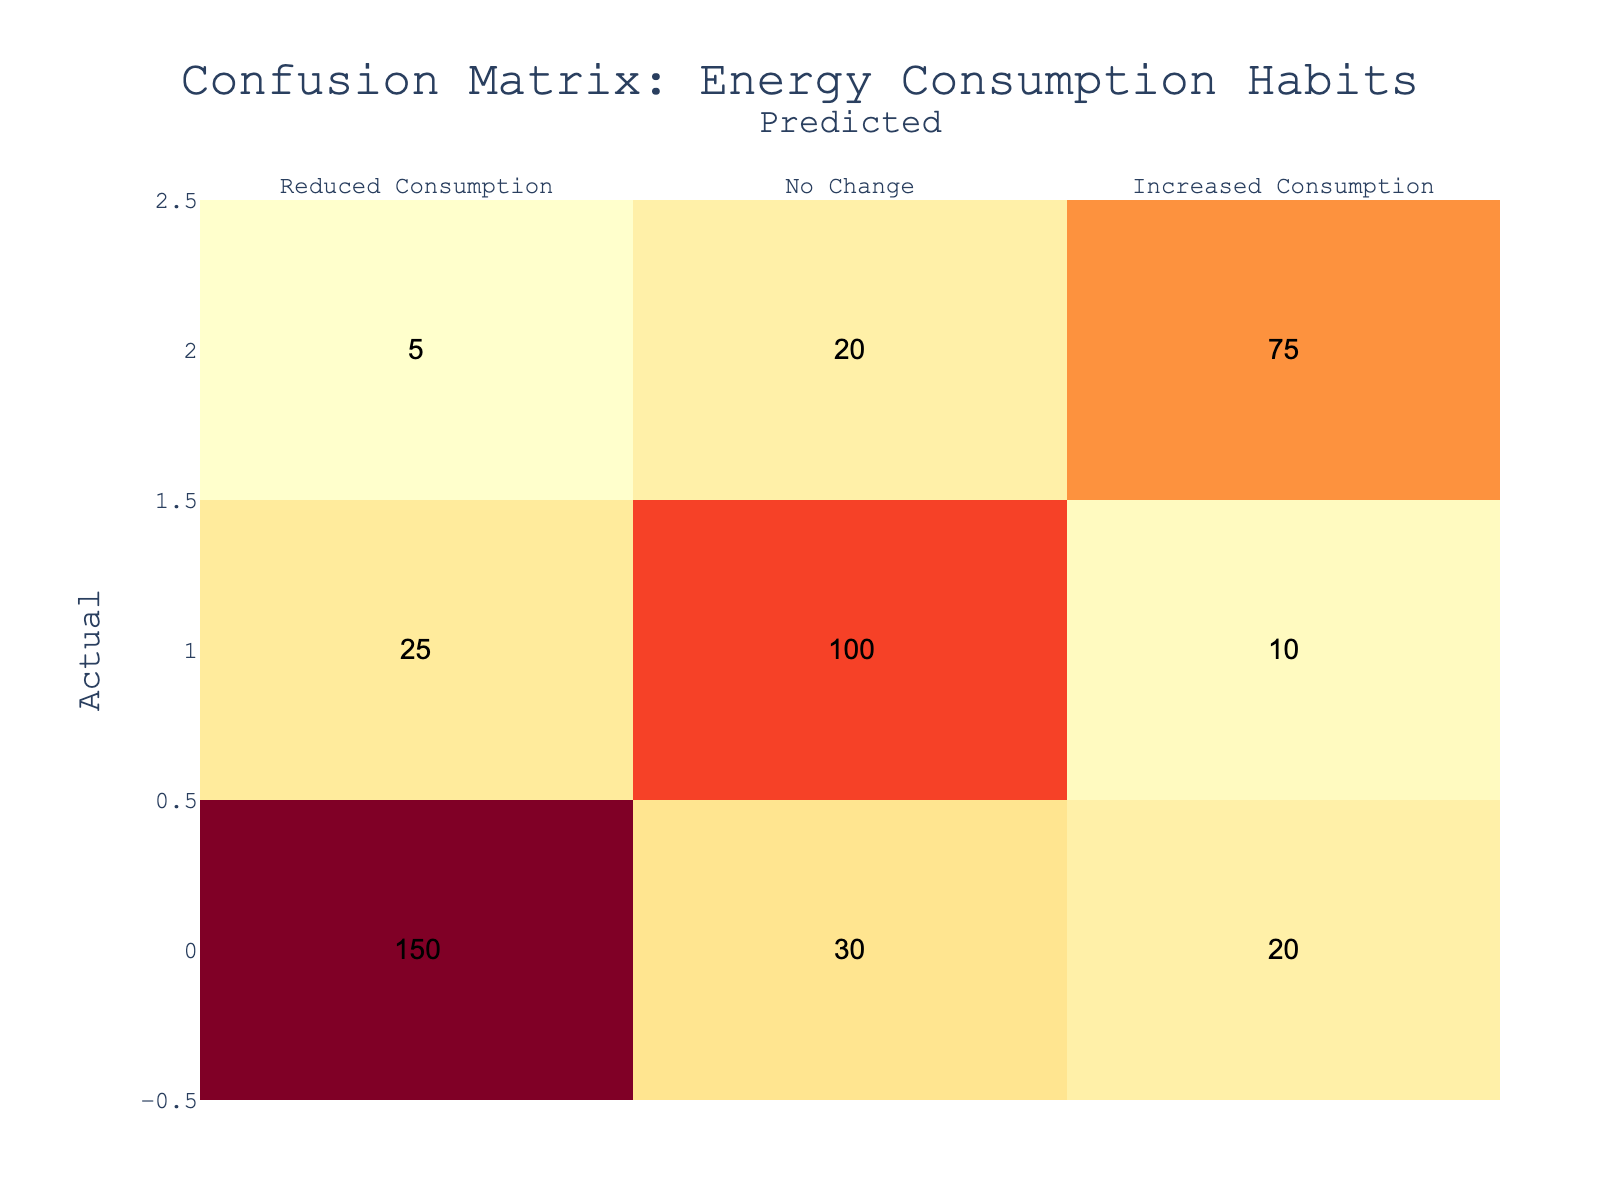What is the number of people who reduced their consumption? According to the table, the number of people who reduced their consumption is represented in the first row under "Reduced Consumption." The value is 150.
Answer: 150 How many individuals experienced no change in consumption? The total number of individuals who experienced no change in their consumption is found in the second row under "No Change," which shows a value of 100.
Answer: 100 What is the total number of individuals whose consumption increased? To find the total number of individuals whose consumption increased, we look at the third row under "Increased Consumption." The value is 75.
Answer: 75 What percentage of people predicted to have increased consumption actually reduced their consumption? There are 20 individuals who were predicted to have increased consumption but actually reduced it. The number of predicted increased consumption is 20 + 10 + 75 = 105. To calculate the percentage, (20/105) * 100 = approximately 19.05%.
Answer: 19.05% Is it true that more people reduced their consumption than those who increased it? Looking at the values, 150 reduced their consumption while 75 increased it. Since 150 is greater than 75, the statement is true.
Answer: Yes What is the overall accuracy of the predictions regarding energy consumption habits? To calculate the overall accuracy, we must sum the correct predictions: 150 (reduced) + 100 (no change) + 75 (increased) = 325. The total predictions made is 150 + 30 + 20 + 25 + 100 + 10 + 5 + 20 + 75 = 435. The accuracy is 325/435 ≈ 0.746 or 74.6%.
Answer: 74.6% How many individuals were incorrectly predicted as having reduced their consumption? The incorrectly predicted group for reduced consumption consists of those marked as "No Change" and "Increased Consumption" when the actual was "Reduced Consumption." It sums up to 30 (predicted no change) + 20 (predicted increased) = 50.
Answer: 50 What can be inferred about the relationship between consumption reduction and climate awareness? Based on the confusion matrix, a significantly high number of people reduced their consumption (150) compared to the predicted values for increased consumption (there are only 20 incorrectly marked). This suggests that climate awareness may influence more individuals to actually reduce their energy consumption.
Answer: It suggests a positive influence of climate awareness 